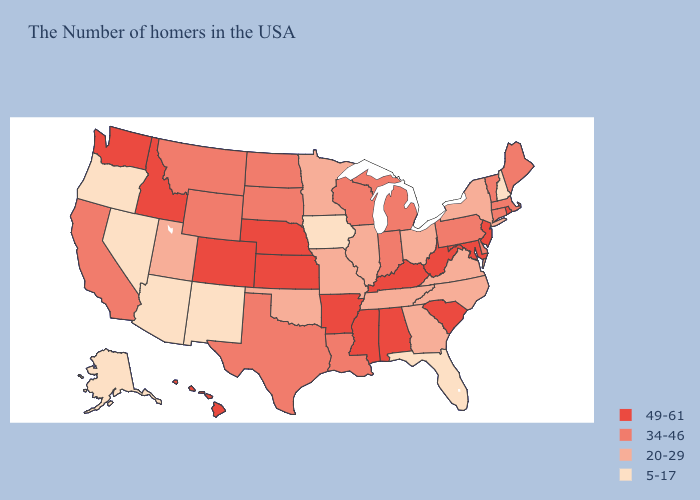What is the highest value in states that border Oklahoma?
Give a very brief answer. 49-61. Among the states that border Nebraska , does Colorado have the lowest value?
Keep it brief. No. Name the states that have a value in the range 5-17?
Short answer required. New Hampshire, Florida, Iowa, New Mexico, Arizona, Nevada, Oregon, Alaska. Name the states that have a value in the range 5-17?
Short answer required. New Hampshire, Florida, Iowa, New Mexico, Arizona, Nevada, Oregon, Alaska. Does Pennsylvania have a higher value than Arizona?
Short answer required. Yes. What is the highest value in the MidWest ?
Quick response, please. 49-61. Does Rhode Island have a lower value than Vermont?
Concise answer only. No. What is the value of Oregon?
Short answer required. 5-17. How many symbols are there in the legend?
Give a very brief answer. 4. What is the lowest value in the USA?
Concise answer only. 5-17. What is the lowest value in states that border Missouri?
Answer briefly. 5-17. Name the states that have a value in the range 5-17?
Short answer required. New Hampshire, Florida, Iowa, New Mexico, Arizona, Nevada, Oregon, Alaska. Which states have the lowest value in the MidWest?
Short answer required. Iowa. Among the states that border New Mexico , which have the highest value?
Quick response, please. Colorado. 